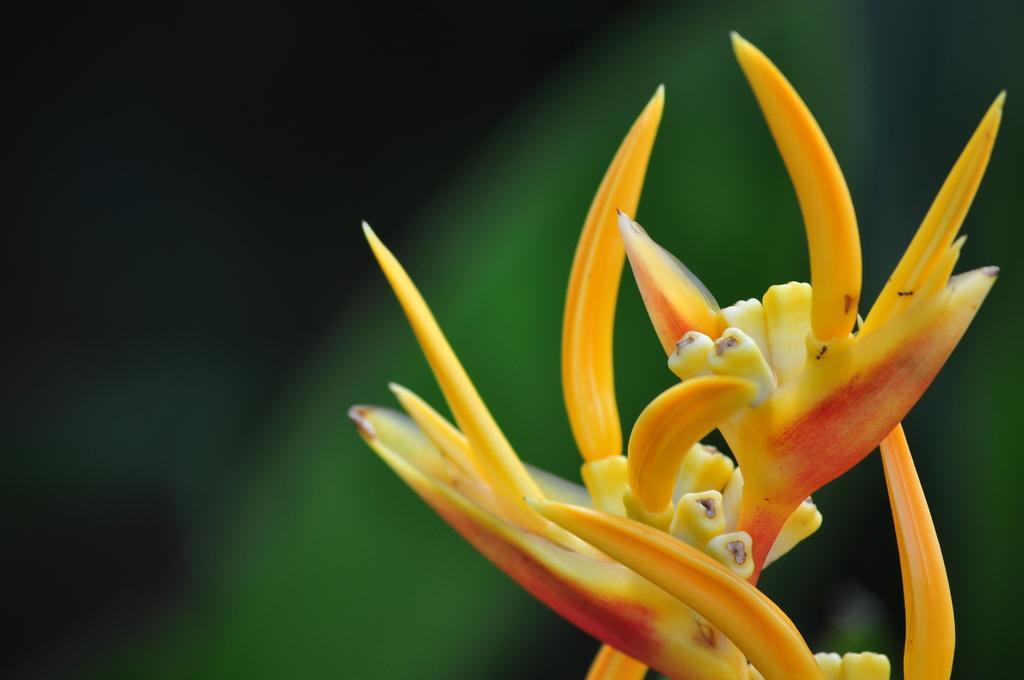Please provide a concise description of this image. In this image we can see a flower which is in yellow and red color and the background image is blur. 